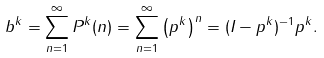<formula> <loc_0><loc_0><loc_500><loc_500>b ^ { k } = \sum _ { n = 1 } ^ { \infty } P ^ { k } ( n ) = \sum _ { n = 1 } ^ { \infty } \left ( p ^ { k } \right ) ^ { n } = ( I - p ^ { k } ) ^ { - 1 } p ^ { k } .</formula> 